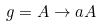<formula> <loc_0><loc_0><loc_500><loc_500>g = A \rightarrow a A</formula> 